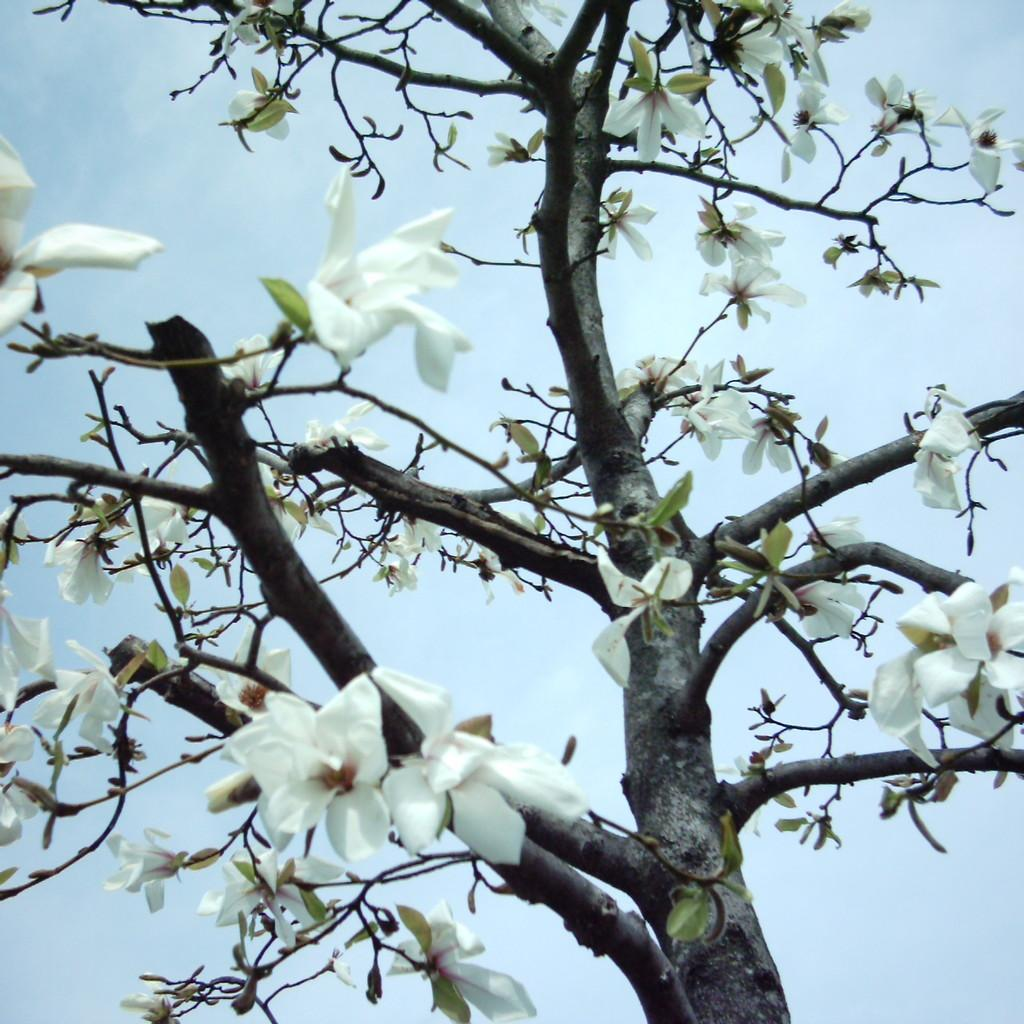What is the main subject of the image? The main subject of the image is a tree. What can be observed about the tree's appearance? The tree has white flowers on it. What can be seen in the background of the image? The sky is visible in the background of the image. Where is the airport located in the image? There is no airport present in the image; it features a tree with white flowers and a visible sky in the background. What type of quiver is hanging from the tree in the image? There is no quiver present in the image; it features a tree with white flowers and a visible sky in the background. 